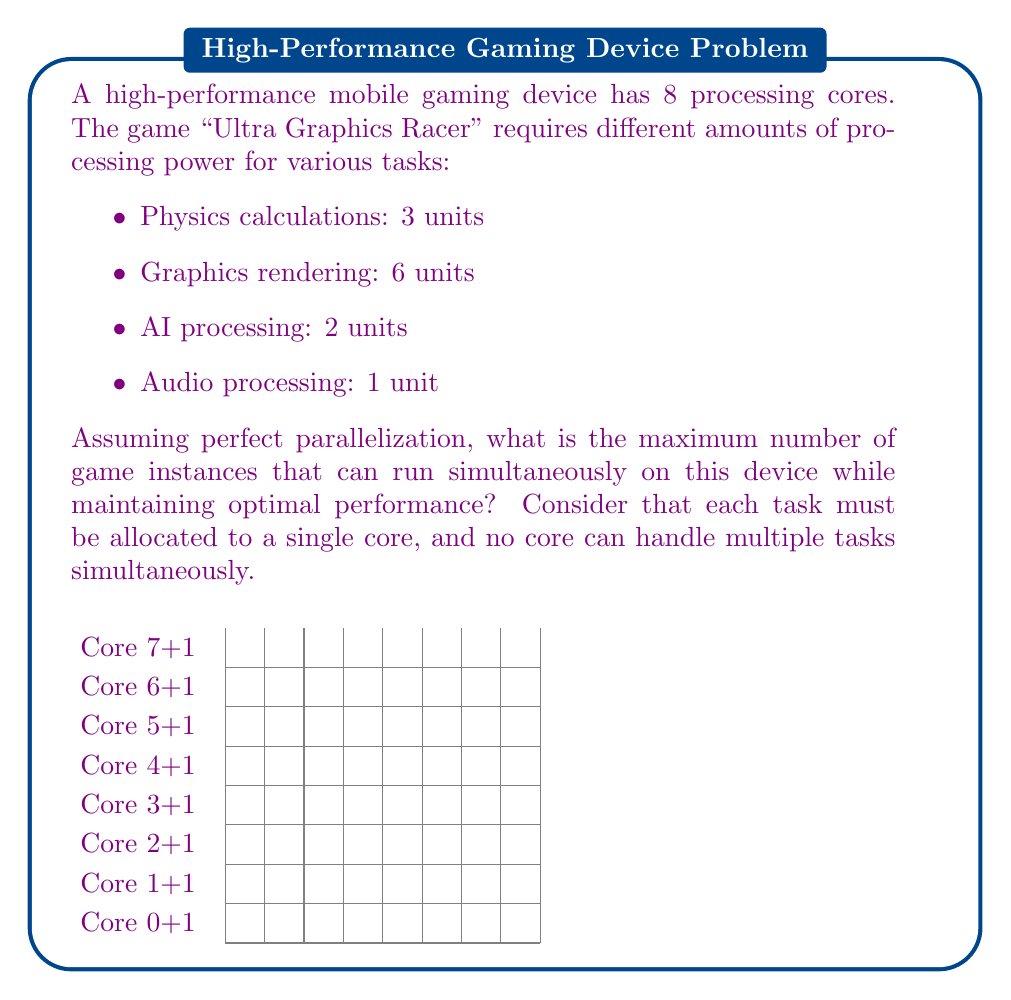Show me your answer to this math problem. To solve this problem, we need to follow these steps:

1. Calculate the total processing units required for one game instance:
   $$ \text{Total units} = 3 + 6 + 2 + 1 = 12 \text{ units} $$

2. Determine how many cores are needed for one game instance:
   Since each task must be allocated to a single core, we need at least 4 cores for one game instance (one for each task).

3. Check if the available cores (8) are sufficient for multiple instances:
   8 cores can potentially support 2 game instances (4 cores each).

4. Verify if the processing units required for 2 instances fit within the 8 cores:
   $$ \text{Units for 2 instances} = 12 \times 2 = 24 \text{ units} $$
   
   Distribution of units across 8 cores:
   - Core 1 & 2: Physics (3 units each)
   - Core 3 & 4: Graphics (6 units each)
   - Core 5 & 6: AI (2 units each)
   - Core 7 & 8: Audio (1 unit each)

   This distribution fits perfectly within the 8 available cores.

5. Check if a third instance is possible:
   A third instance would require 12 more units and 4 more cores, which exceeds the available resources.

Therefore, the maximum number of game instances that can run simultaneously while maintaining optimal performance is 2.
Answer: 2 instances 